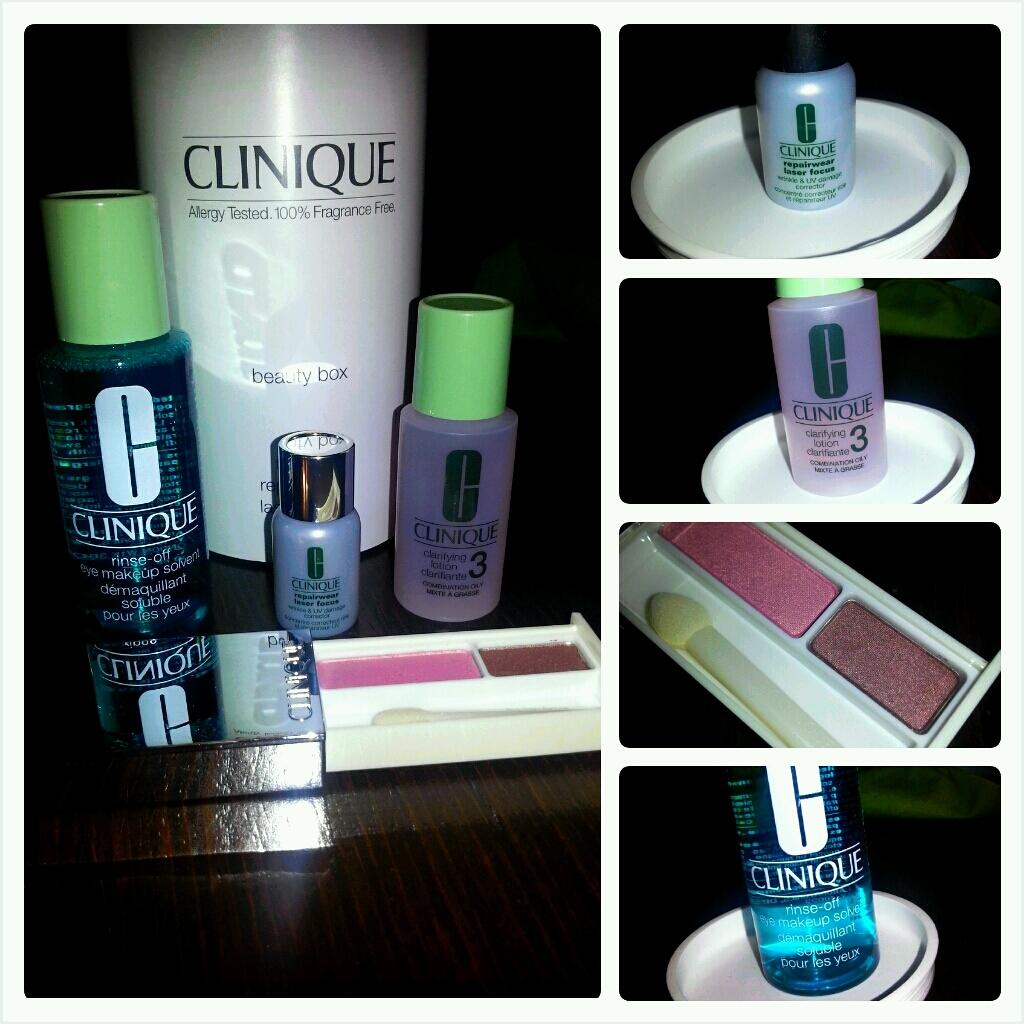<image>
Share a concise interpretation of the image provided. A grouping of toiletry and cosmetic items from the Clinique brand. 